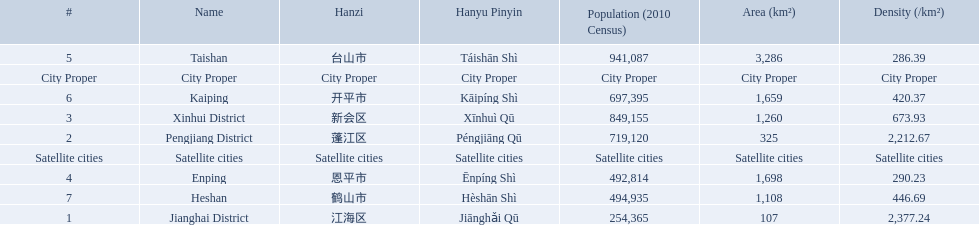What cities are there in jiangmen? Jianghai District, Pengjiang District, Xinhui District, Enping, Taishan, Kaiping, Heshan. Of those, which ones are a city proper? Jianghai District, Pengjiang District, Xinhui District. Of those, which one has the smallest area in km2? Jianghai District. 